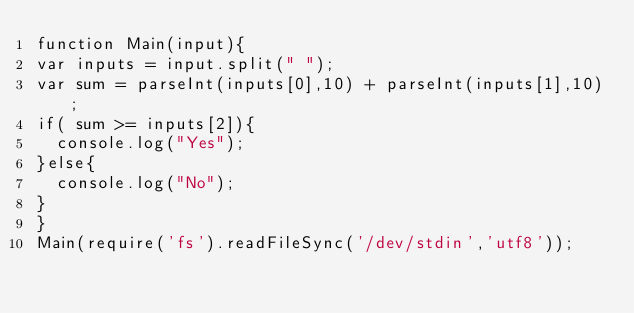<code> <loc_0><loc_0><loc_500><loc_500><_JavaScript_>function Main(input){
var inputs = input.split(" ");
var sum = parseInt(inputs[0],10) + parseInt(inputs[1],10);
if( sum >= inputs[2]){
  console.log("Yes");
}else{
  console.log("No");
}
}
Main(require('fs').readFileSync('/dev/stdin','utf8'));</code> 